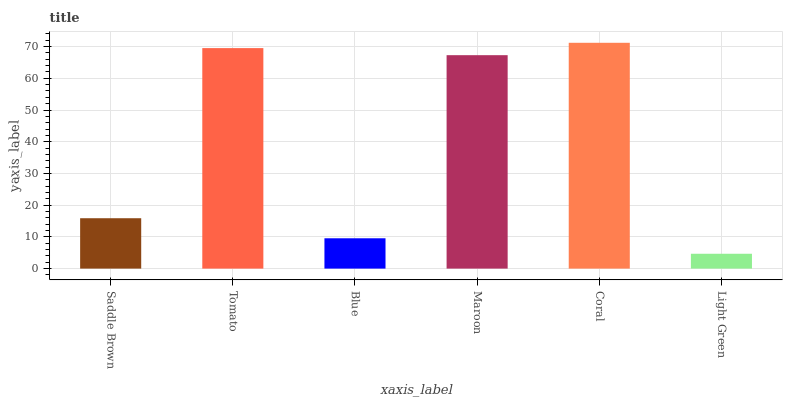Is Coral the maximum?
Answer yes or no. Yes. Is Tomato the minimum?
Answer yes or no. No. Is Tomato the maximum?
Answer yes or no. No. Is Tomato greater than Saddle Brown?
Answer yes or no. Yes. Is Saddle Brown less than Tomato?
Answer yes or no. Yes. Is Saddle Brown greater than Tomato?
Answer yes or no. No. Is Tomato less than Saddle Brown?
Answer yes or no. No. Is Maroon the high median?
Answer yes or no. Yes. Is Saddle Brown the low median?
Answer yes or no. Yes. Is Light Green the high median?
Answer yes or no. No. Is Light Green the low median?
Answer yes or no. No. 